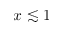<formula> <loc_0><loc_0><loc_500><loc_500>x \lesssim 1</formula> 